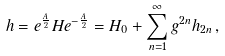<formula> <loc_0><loc_0><loc_500><loc_500>h = e ^ { \frac { A } { 2 } } H e ^ { - \frac { A } { 2 } } = H _ { 0 } + \sum _ { n = 1 } ^ { \infty } g ^ { 2 n } h _ { 2 n } \, ,</formula> 